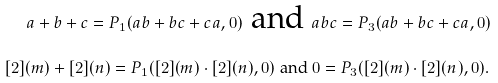<formula> <loc_0><loc_0><loc_500><loc_500>a + b + c = P _ { 1 } ( a b + b c + c a , 0 ) \text { and } & a b c = P _ { 3 } ( a b + b c + c a , 0 ) \\ [ 2 ] ( m ) + [ 2 ] ( n ) = P _ { 1 } ( [ 2 ] ( m ) \cdot [ 2 ] ( n ) , 0 ) \text { and } & 0 = P _ { 3 } ( [ 2 ] ( m ) \cdot [ 2 ] ( n ) , 0 ) .</formula> 